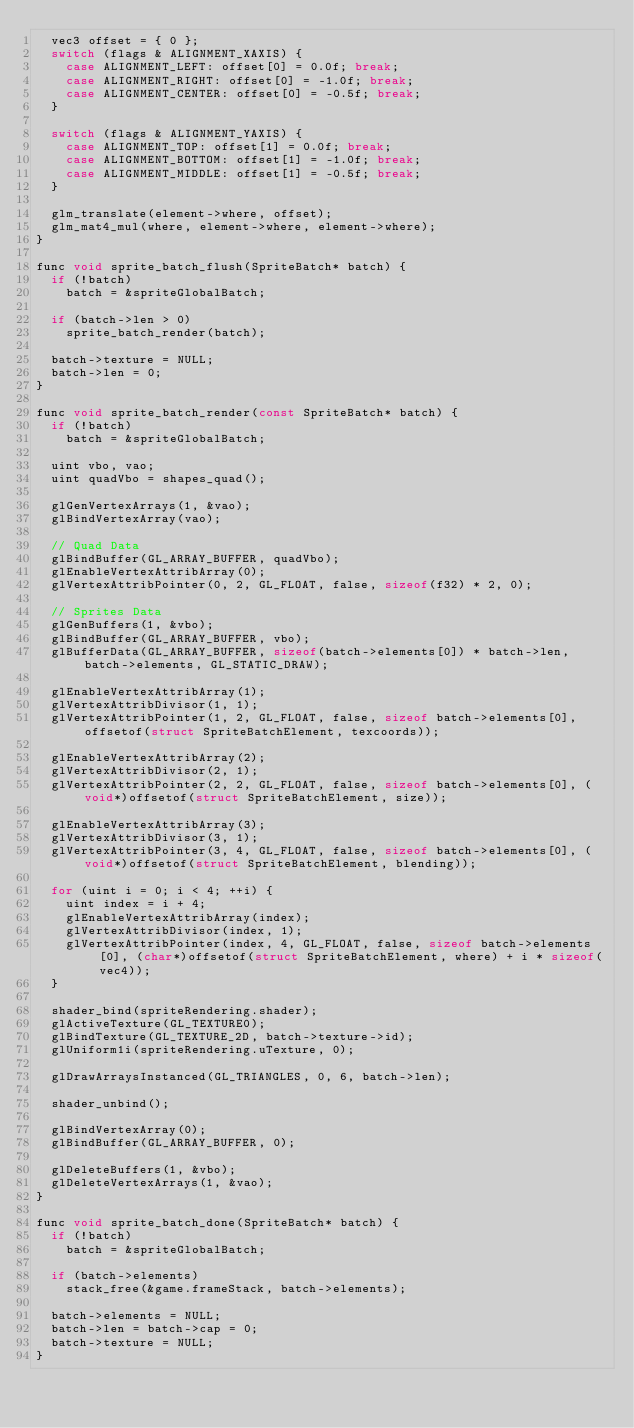<code> <loc_0><loc_0><loc_500><loc_500><_C_>	vec3 offset = { 0 };
	switch (flags & ALIGNMENT_XAXIS) {
		case ALIGNMENT_LEFT: offset[0] = 0.0f; break;
		case ALIGNMENT_RIGHT: offset[0] = -1.0f; break;
		case ALIGNMENT_CENTER: offset[0] = -0.5f; break;
	}
	
	switch (flags & ALIGNMENT_YAXIS) {
		case ALIGNMENT_TOP: offset[1] = 0.0f; break;
		case ALIGNMENT_BOTTOM: offset[1] = -1.0f; break;
		case ALIGNMENT_MIDDLE: offset[1] = -0.5f; break;
	}
	
	glm_translate(element->where, offset);
	glm_mat4_mul(where, element->where, element->where);
}

func void sprite_batch_flush(SpriteBatch* batch) {
	if (!batch)
		batch = &spriteGlobalBatch;
	
	if (batch->len > 0)
		sprite_batch_render(batch);
	
	batch->texture = NULL;
	batch->len = 0;
}

func void sprite_batch_render(const SpriteBatch* batch) {
	if (!batch)
		batch = &spriteGlobalBatch;
	
	uint vbo, vao;
	uint quadVbo = shapes_quad();
	
	glGenVertexArrays(1, &vao);
	glBindVertexArray(vao);
	
	// Quad Data
	glBindBuffer(GL_ARRAY_BUFFER, quadVbo);
	glEnableVertexAttribArray(0);
	glVertexAttribPointer(0, 2, GL_FLOAT, false, sizeof(f32) * 2, 0);
	
	// Sprites Data
	glGenBuffers(1, &vbo);
	glBindBuffer(GL_ARRAY_BUFFER, vbo);
	glBufferData(GL_ARRAY_BUFFER, sizeof(batch->elements[0]) * batch->len, batch->elements, GL_STATIC_DRAW);
	
	glEnableVertexAttribArray(1);
	glVertexAttribDivisor(1, 1);
	glVertexAttribPointer(1, 2, GL_FLOAT, false, sizeof batch->elements[0], offsetof(struct SpriteBatchElement, texcoords));
	
	glEnableVertexAttribArray(2);
	glVertexAttribDivisor(2, 1);
	glVertexAttribPointer(2, 2, GL_FLOAT, false, sizeof batch->elements[0], (void*)offsetof(struct SpriteBatchElement, size));
	
	glEnableVertexAttribArray(3);
	glVertexAttribDivisor(3, 1);
	glVertexAttribPointer(3, 4, GL_FLOAT, false, sizeof batch->elements[0], (void*)offsetof(struct SpriteBatchElement, blending));
	
	for (uint i = 0; i < 4; ++i) {
		uint index = i + 4;
		glEnableVertexAttribArray(index);
		glVertexAttribDivisor(index, 1);
		glVertexAttribPointer(index, 4, GL_FLOAT, false, sizeof batch->elements[0], (char*)offsetof(struct SpriteBatchElement, where) + i * sizeof(vec4));
	}
	
	shader_bind(spriteRendering.shader);
	glActiveTexture(GL_TEXTURE0);
	glBindTexture(GL_TEXTURE_2D, batch->texture->id);
	glUniform1i(spriteRendering.uTexture, 0);
	
	glDrawArraysInstanced(GL_TRIANGLES, 0, 6, batch->len);
	
	shader_unbind();
	
	glBindVertexArray(0);
	glBindBuffer(GL_ARRAY_BUFFER, 0);
	
	glDeleteBuffers(1, &vbo);
	glDeleteVertexArrays(1, &vao);
}

func void sprite_batch_done(SpriteBatch* batch) {
	if (!batch)
		batch = &spriteGlobalBatch;
	
	if (batch->elements)
		stack_free(&game.frameStack, batch->elements);
	
	batch->elements = NULL;
	batch->len = batch->cap = 0;
	batch->texture = NULL;
}

</code> 